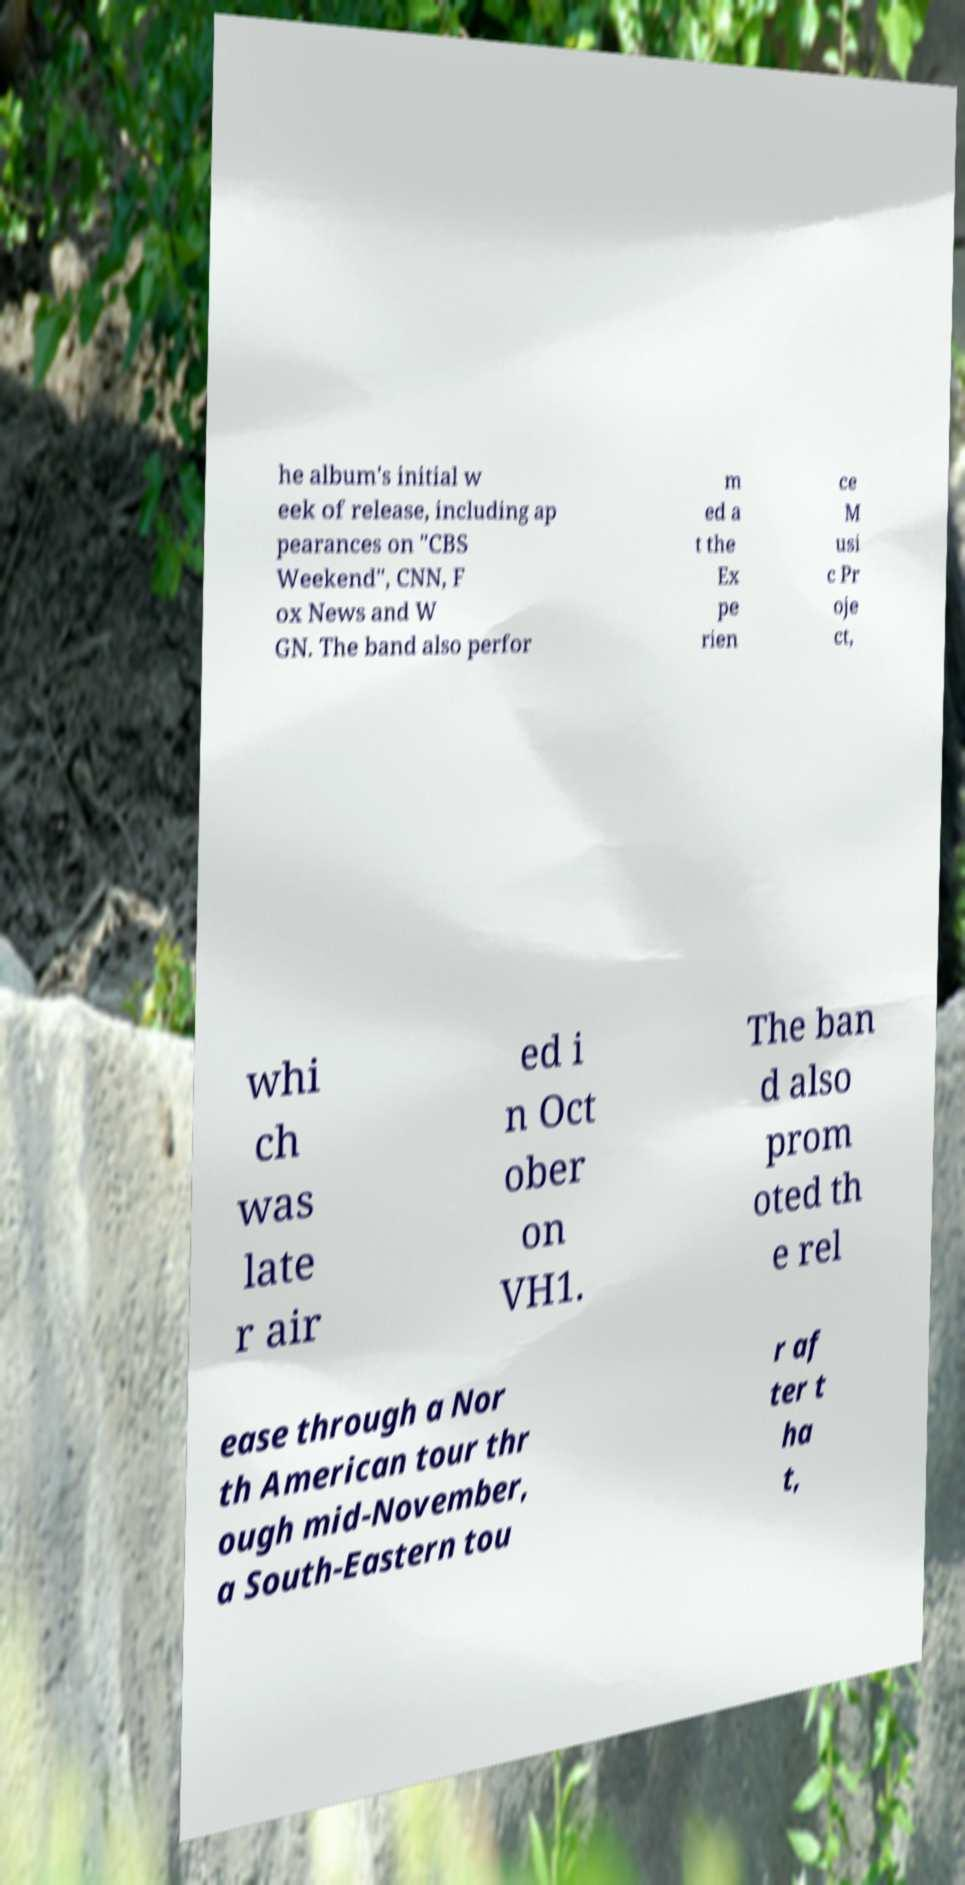There's text embedded in this image that I need extracted. Can you transcribe it verbatim? he album's initial w eek of release, including ap pearances on "CBS Weekend", CNN, F ox News and W GN. The band also perfor m ed a t the Ex pe rien ce M usi c Pr oje ct, whi ch was late r air ed i n Oct ober on VH1. The ban d also prom oted th e rel ease through a Nor th American tour thr ough mid-November, a South-Eastern tou r af ter t ha t, 